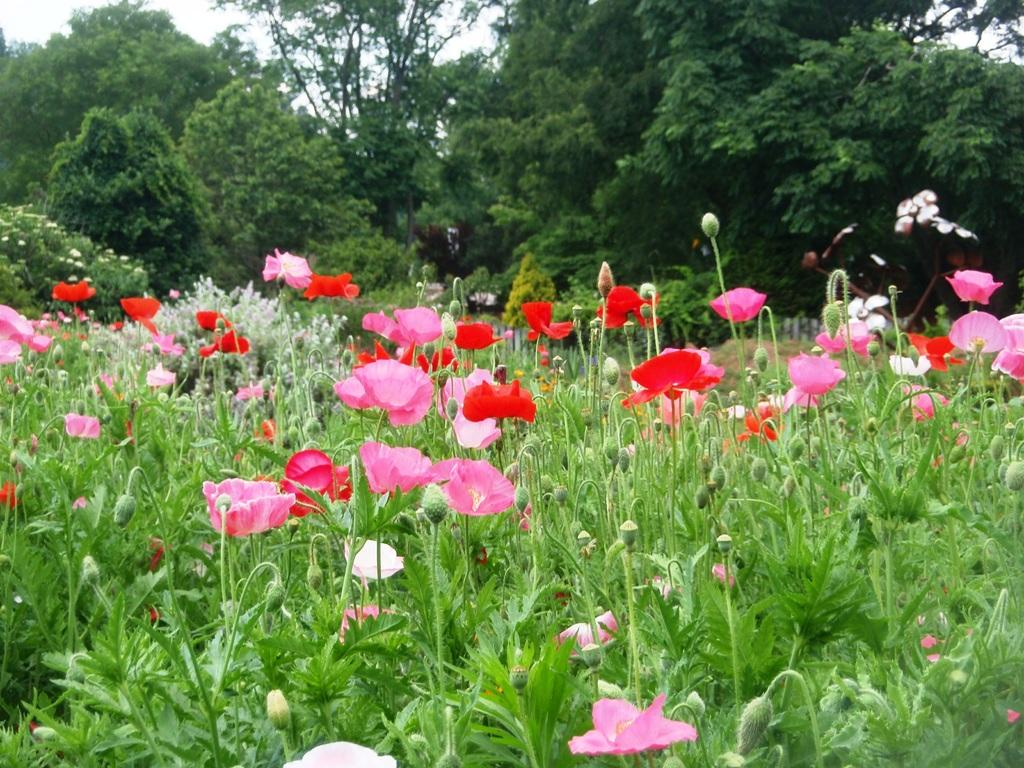What type of vegetation can be seen in the image? There are flowers, plants, and trees in the image. Can you describe the different types of vegetation present? The image contains flowers, which are smaller and more colorful, plants, which are typically green and leafy, and trees, which are larger and have a woody trunk. How many different types of vegetation are present in the image? There are three different types of vegetation present in the image: flowers, plants, and trees. What type of yam is being served on the stage in the image? There is no stage or yam present in the image; it features flowers, plants, and trees. Can you tell me how many chickens are perched on the branches of the trees in the image? There are no chickens present in the image; it features flowers, plants, and trees. 